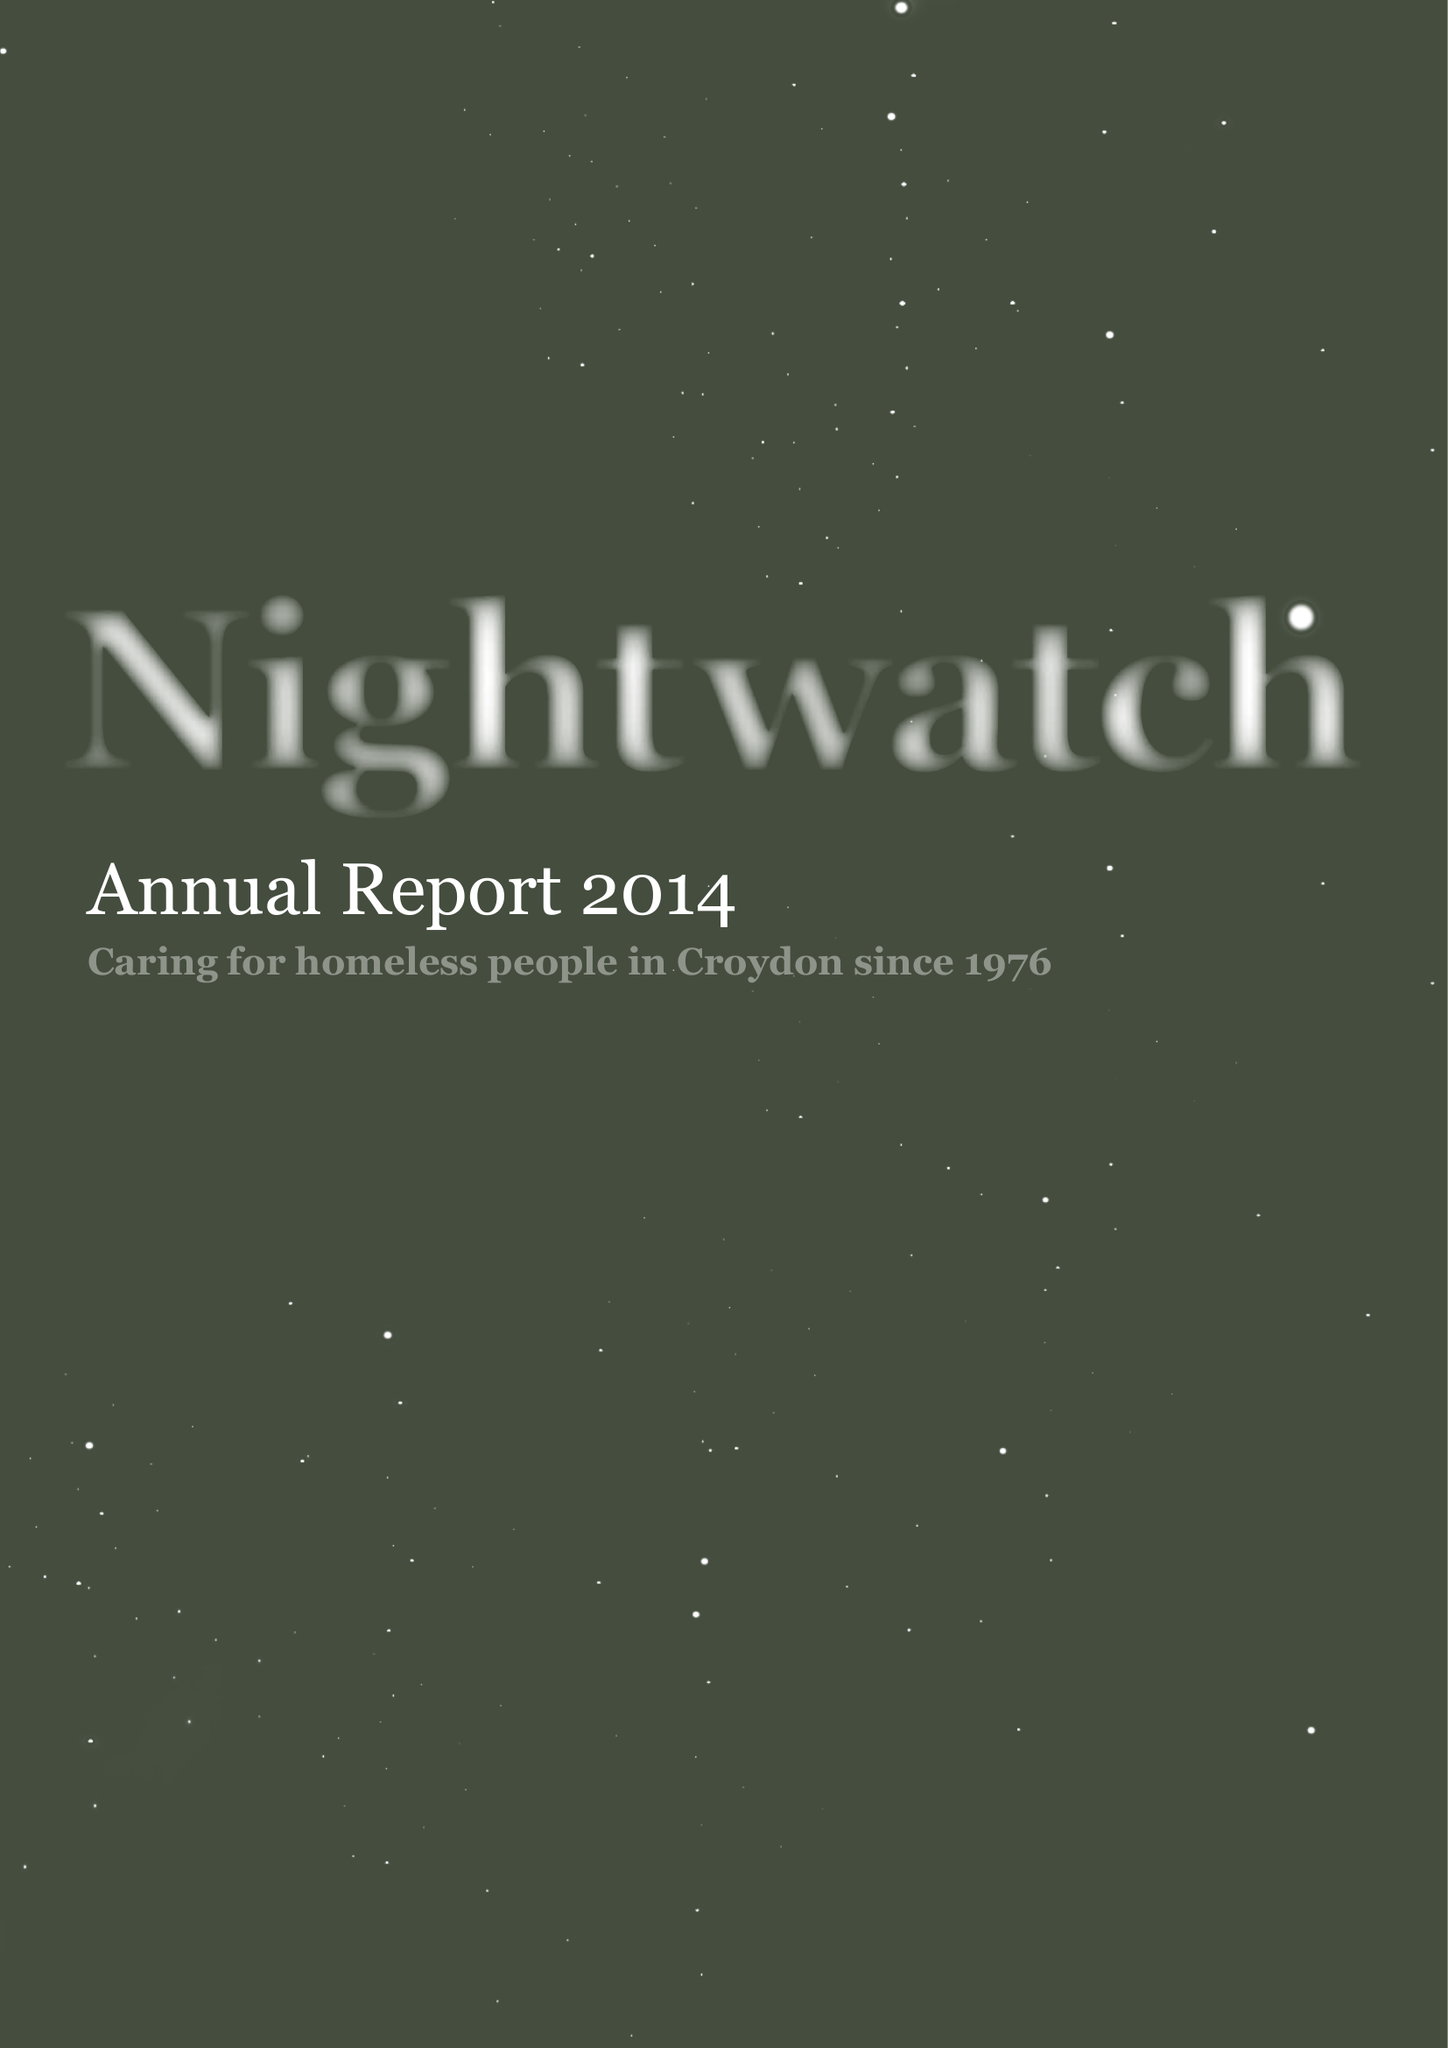What is the value for the address__street_line?
Answer the question using a single word or phrase. PO BOX 9576 